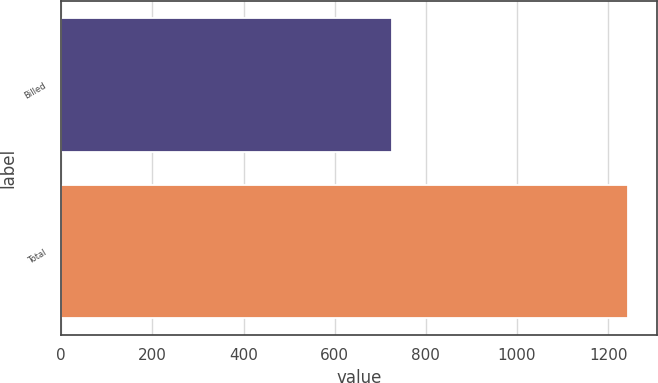<chart> <loc_0><loc_0><loc_500><loc_500><bar_chart><fcel>Billed<fcel>Total<nl><fcel>725<fcel>1244<nl></chart> 